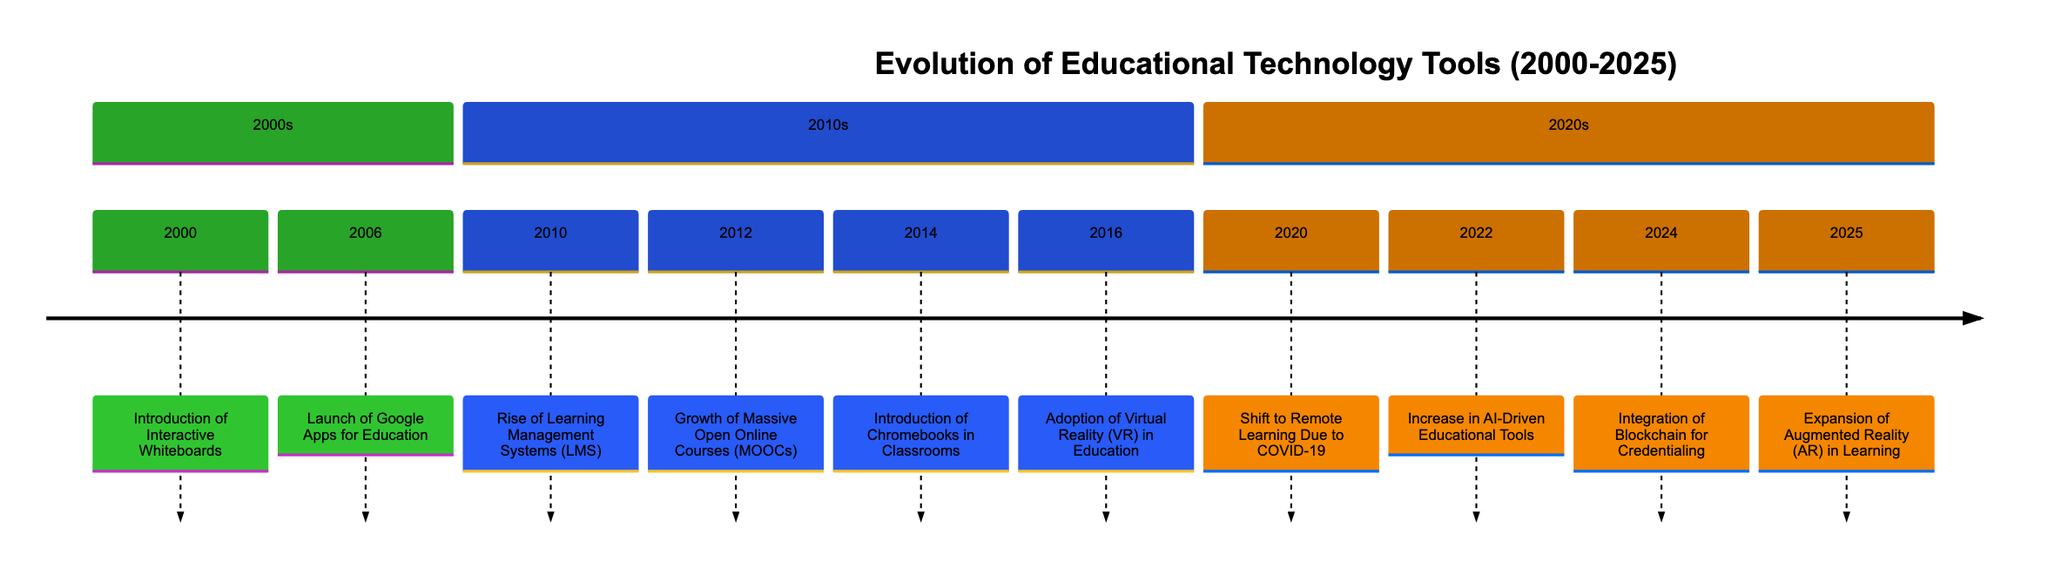What event introduced interactive whiteboards? This can be found in the timeline for the year 2000, where it states the event "Introduction of Interactive Whiteboards."
Answer: Introduction of Interactive Whiteboards Which year marked the launch of Google Apps for Education? In the timeline, the event "Launch of Google Apps for Education" is listed under the year 2006.
Answer: 2006 How many significant events are listed in the 2010s section? By counting the events listed in the 2010s section of the timeline, we can see there are five notable events detailed.
Answer: 5 What was a major focus of education technology introduced in 2020? The description for the year 2020 explains that the Shift to Remote Learning Due to COVID-19 was a significant educational technology shift that year.
Answer: Shift to Remote Learning Due to COVID-19 What technology began to gain traction in 2014 for classroom use? The timeline shows that the Introduction of Chromebooks in Classrooms was the significant technology acknowledged in 2014, highlighting its popularity among educators.
Answer: Introduction of Chromebooks in Classrooms In what year did the adoption of virtual reality in education occur? The event Adoption of Virtual Reality (VR) in Education is explicitly noted as occurring in the year 2016 within the timeline.
Answer: 2016 Which two technologies were introduced in 2022? Looking at the timeline, it's indicated that the Increase in AI-Driven Educational Tools and the tools like ChatGPT and language learning apps were introduced that year, thus both should be considered.
Answer: Increase in AI-Driven Educational Tools What is the expected advancement in education technology for 2025? The description for 2025 elaborates on the Expansion of Augmented Reality (AR) in Learning as an anticipated development for that year.
Answer: Expansion of Augmented Reality (AR) in Learning Which educational technology trend emerged due to the global pandemic? The timeline entry for 2020 specifically refers to the Shift to Remote Learning Due to COVID-19, making this trend clear.
Answer: Shift to Remote Learning Due to COVID-19 